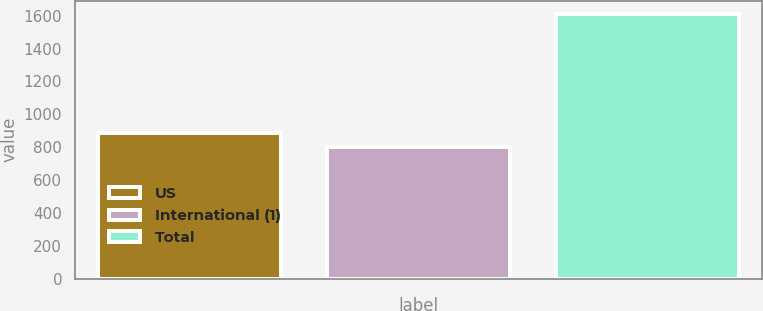Convert chart. <chart><loc_0><loc_0><loc_500><loc_500><bar_chart><fcel>US<fcel>International (1)<fcel>Total<nl><fcel>883.6<fcel>803<fcel>1609<nl></chart> 